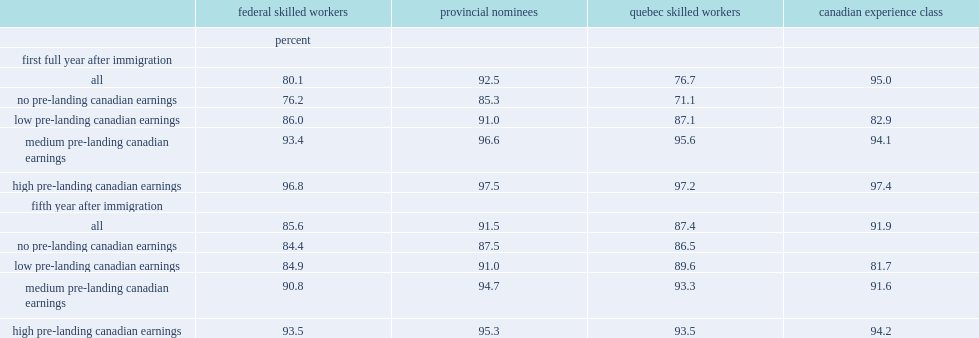What percentages are the employment incidence for cec immigrants higher than fswp immigrants in the first year and fifth year respectively? 14.9 6.3. 